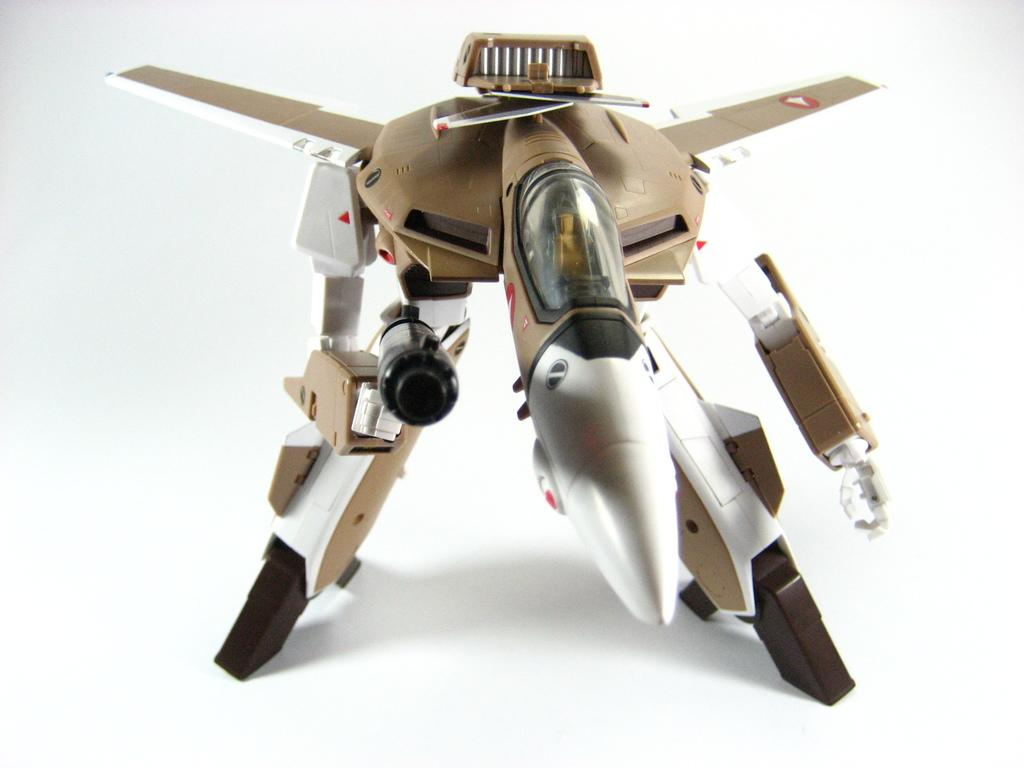What is the main subject of the image? The main subject of the image is a toy robot. Where is the toy robot located in the image? The toy robot is placed on a surface in the image. How much tax is being charged on the toy robot in the image? There is no indication of tax or any financial transaction in the image, as it features a toy robot placed on a surface. 